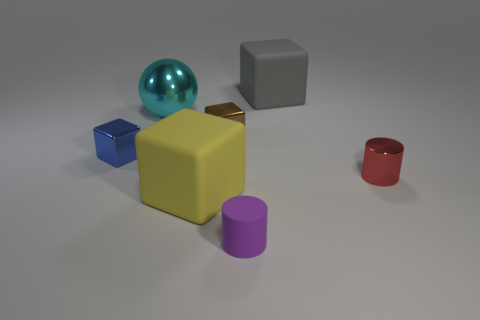Subtract all brown shiny cubes. How many cubes are left? 3 Add 1 small green rubber cylinders. How many objects exist? 8 Subtract all red cylinders. How many cylinders are left? 1 Subtract all spheres. How many objects are left? 6 Subtract all green cubes. Subtract all yellow spheres. How many cubes are left? 4 Subtract all yellow cubes. Subtract all tiny red objects. How many objects are left? 5 Add 2 small brown metallic objects. How many small brown metallic objects are left? 3 Add 6 purple rubber spheres. How many purple rubber spheres exist? 6 Subtract 0 brown spheres. How many objects are left? 7 